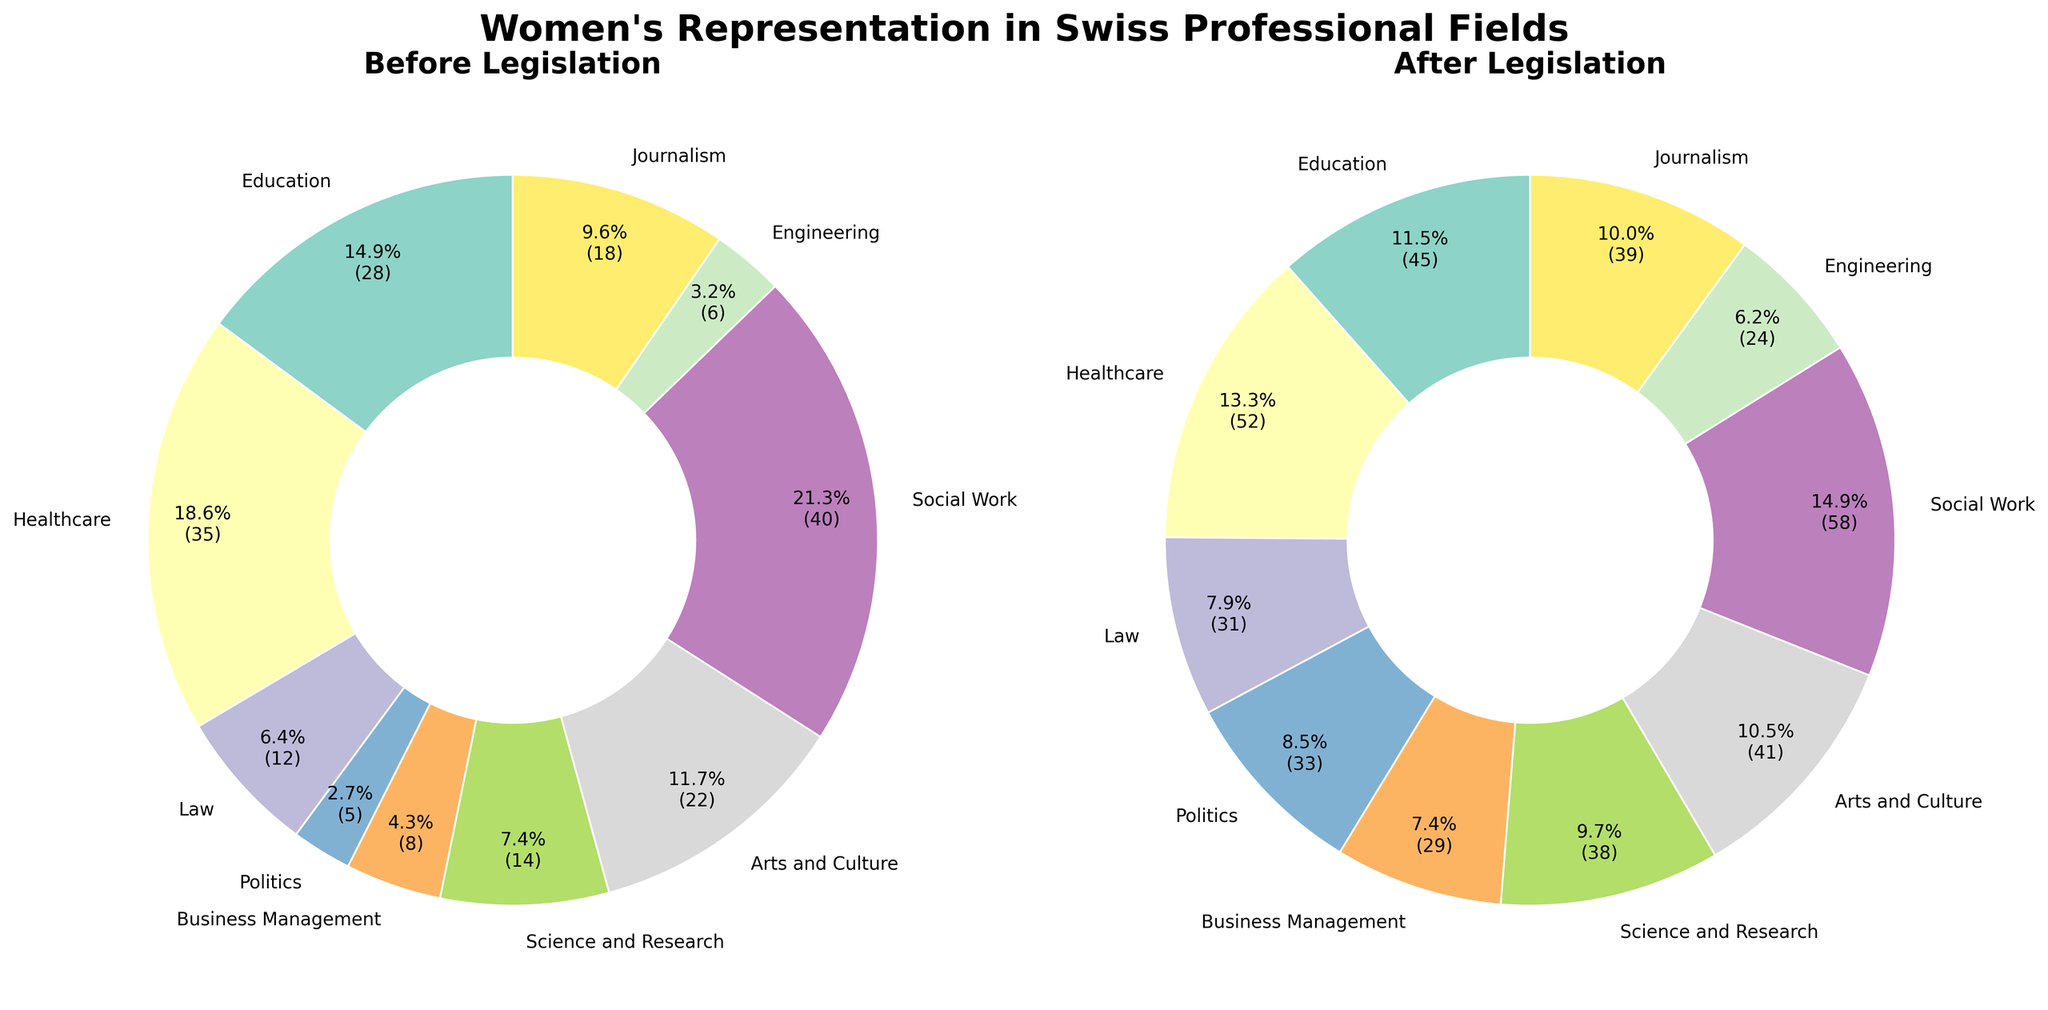Which professional field saw the highest percentage increase after the legislation? By comparing the percentage values before and after the legislation for each field, Politics increased from 5% to 33%, which is an increase of 28 percentage points. No other field shows a higher increase.
Answer: Politics Which field had the least representation before the legislation? By looking at the 'Before Legislation' percentages, Engineering had the lowest representation with 6%.
Answer: Engineering What is the difference in the percentage of women in Healthcare before and after legislation? The percentage of women in Healthcare before the legislation was 35% and after was 52%. The difference is 52% - 35% = 17%.
Answer: 17% Which fields saw an increase of more than 20 percentage points after the legislation? By comparing the before and after percentages: Education (17%), Healthcare (17%), Law (19%), Politics (28%), Business Management (21%), Science and Research (24%), Arts and Culture (19%), Social Work (18%), Engineering (18%), Journalism (21%). Only Politics, Business Management, Science and Research, and Journalism had increases greater than 20 percentage points.
Answer: Politics, Business Management, Science and Research, Journalism What is the combined percentage of women in Science and Research and Engineering after the legislation? The percentage of women in Science and Research after legislation is 38% and in Engineering is 24%. The combined percentage is 38% + 24% = 62%.
Answer: 62% How does the representation of women in Business Management compare before and after legislation? Before legislation, the percentage was 8%, and after, it increased to 29%. This represents a 21 percentage point increase, almost four times higher than before.
Answer: Increased by 21 percentage points Which professional fields have more than doubled their representation after the legislation? Comparing the percentages before and after legislation: Education (from 28% to 45%), Healthcare (from 35% to 52%), Law (from 12% to 31%), Politics (from 5% to 33%), Business Management (from 8% to 29%), Science and Research (from 14% to 38%), Arts and Culture (from 22% to 41%), Social Work (from 40% to 58%), Engineering (from 6% to 24%), Journalism (from 18% to 39%). The fields that more than doubled their representation are Law, Politics, Business Management, Science and Research, Engineering, and Journalism.
Answer: Law, Politics, Business Management, Science and Research, Engineering, Journalism Which field showed the smallest change in representation after the legislation? By comparing all fields: Social Work increased from 40% to 58%, a 18 percentage point change. While other fields have higher or equivalent changes, Social Work has the smallest.
Answer: Social Work 